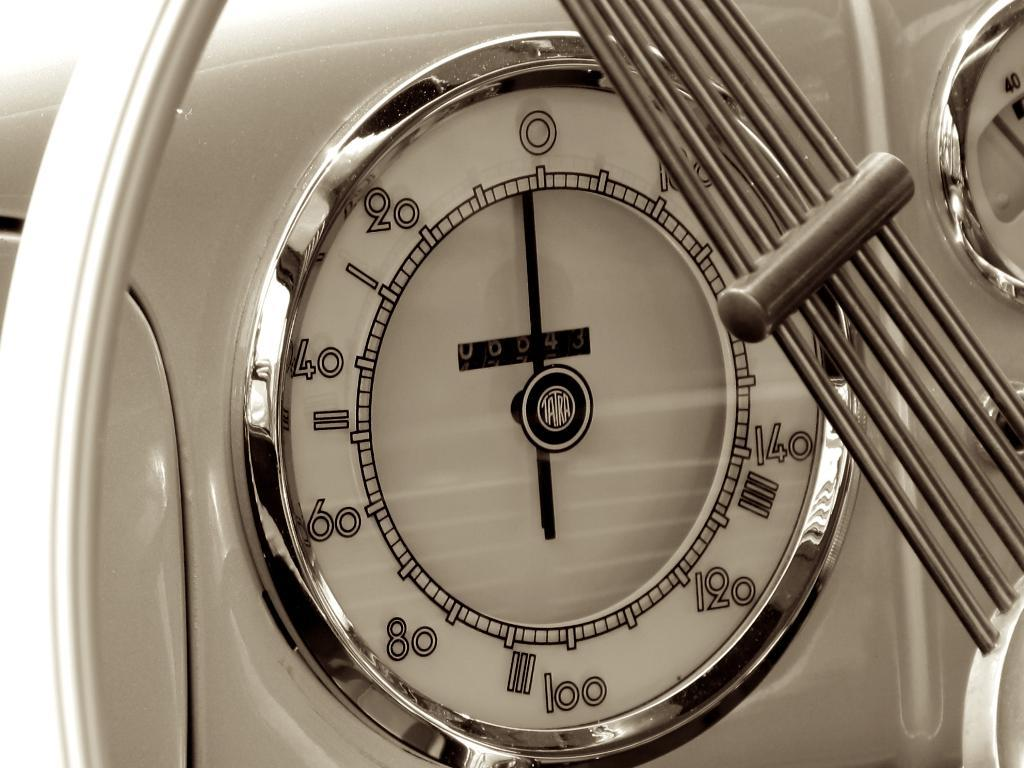Provide a one-sentence caption for the provided image. A kitchen thermometer shows numbers including 20, 40 and 60. 